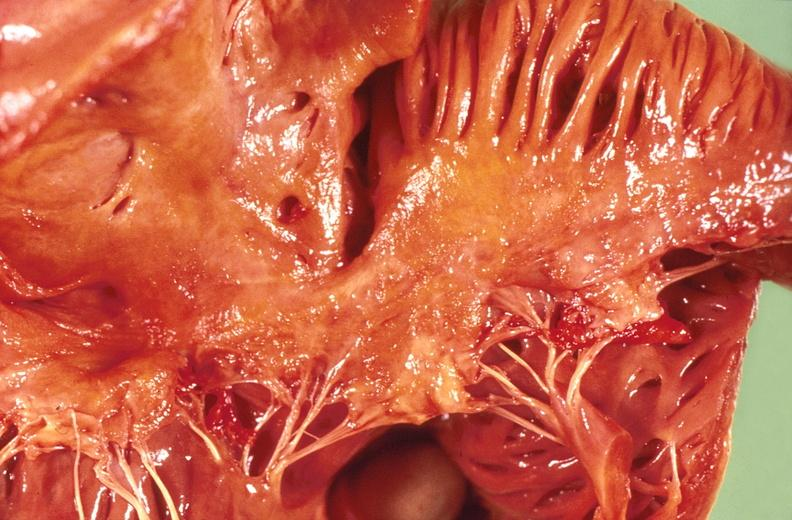s this section showing liver with tumor mass in hilar area tumor present?
Answer the question using a single word or phrase. No 